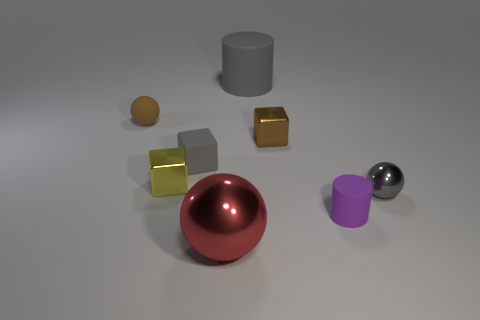Do the brown rubber ball and the gray rubber cylinder have the same size?
Offer a terse response. No. There is a big red thing; is it the same shape as the metal object that is behind the gray block?
Make the answer very short. No. What material is the small brown thing that is to the right of the gray thing behind the brown object that is on the left side of the yellow cube?
Ensure brevity in your answer.  Metal. Is there a shiny sphere of the same size as the gray rubber cylinder?
Give a very brief answer. Yes. The brown ball that is made of the same material as the large gray cylinder is what size?
Provide a short and direct response. Small. What shape is the tiny purple object?
Provide a short and direct response. Cylinder. Is the yellow cube made of the same material as the tiny cube that is right of the big shiny ball?
Keep it short and to the point. Yes. What number of things are large things or tiny purple metal spheres?
Your answer should be compact. 2. Are there any big yellow rubber balls?
Offer a terse response. No. There is a big thing that is left of the cylinder behind the tiny rubber ball; what is its shape?
Offer a terse response. Sphere. 